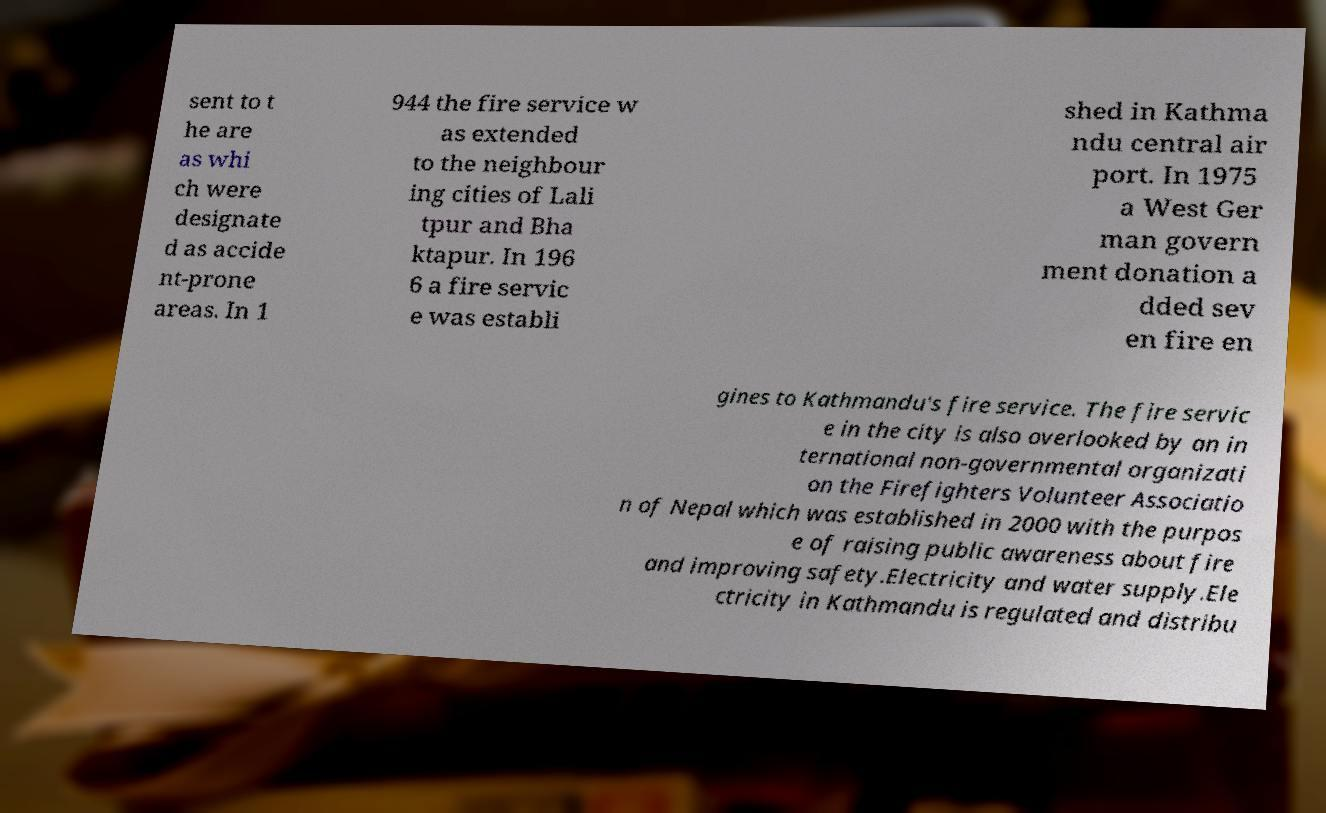There's text embedded in this image that I need extracted. Can you transcribe it verbatim? sent to t he are as whi ch were designate d as accide nt-prone areas. In 1 944 the fire service w as extended to the neighbour ing cities of Lali tpur and Bha ktapur. In 196 6 a fire servic e was establi shed in Kathma ndu central air port. In 1975 a West Ger man govern ment donation a dded sev en fire en gines to Kathmandu's fire service. The fire servic e in the city is also overlooked by an in ternational non-governmental organizati on the Firefighters Volunteer Associatio n of Nepal which was established in 2000 with the purpos e of raising public awareness about fire and improving safety.Electricity and water supply.Ele ctricity in Kathmandu is regulated and distribu 